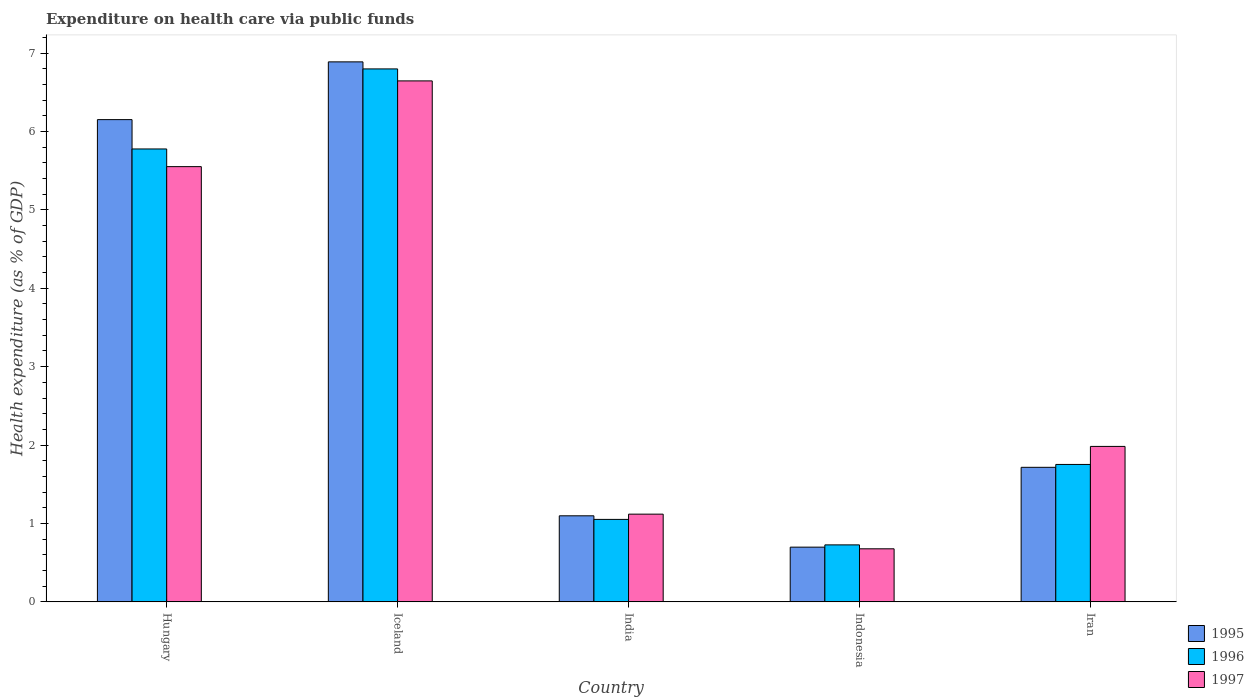How many groups of bars are there?
Ensure brevity in your answer.  5. Are the number of bars on each tick of the X-axis equal?
Give a very brief answer. Yes. What is the label of the 4th group of bars from the left?
Your answer should be compact. Indonesia. What is the expenditure made on health care in 1997 in Indonesia?
Ensure brevity in your answer.  0.68. Across all countries, what is the maximum expenditure made on health care in 1996?
Ensure brevity in your answer.  6.8. Across all countries, what is the minimum expenditure made on health care in 1996?
Offer a very short reply. 0.73. In which country was the expenditure made on health care in 1996 minimum?
Your response must be concise. Indonesia. What is the total expenditure made on health care in 1995 in the graph?
Offer a terse response. 16.55. What is the difference between the expenditure made on health care in 1995 in Hungary and that in India?
Provide a succinct answer. 5.05. What is the difference between the expenditure made on health care in 1997 in Iceland and the expenditure made on health care in 1995 in Iran?
Your answer should be compact. 4.93. What is the average expenditure made on health care in 1995 per country?
Ensure brevity in your answer.  3.31. What is the difference between the expenditure made on health care of/in 1995 and expenditure made on health care of/in 1996 in India?
Make the answer very short. 0.05. In how many countries, is the expenditure made on health care in 1995 greater than 5.6 %?
Ensure brevity in your answer.  2. What is the ratio of the expenditure made on health care in 1996 in India to that in Iran?
Ensure brevity in your answer.  0.6. Is the difference between the expenditure made on health care in 1995 in Hungary and India greater than the difference between the expenditure made on health care in 1996 in Hungary and India?
Ensure brevity in your answer.  Yes. What is the difference between the highest and the second highest expenditure made on health care in 1997?
Offer a very short reply. -3.57. What is the difference between the highest and the lowest expenditure made on health care in 1995?
Provide a short and direct response. 6.19. Is the sum of the expenditure made on health care in 1996 in India and Indonesia greater than the maximum expenditure made on health care in 1997 across all countries?
Offer a terse response. No. What does the 2nd bar from the left in Hungary represents?
Your response must be concise. 1996. How many bars are there?
Offer a very short reply. 15. Are the values on the major ticks of Y-axis written in scientific E-notation?
Provide a short and direct response. No. Does the graph contain any zero values?
Provide a short and direct response. No. Does the graph contain grids?
Provide a short and direct response. No. Where does the legend appear in the graph?
Provide a succinct answer. Bottom right. How many legend labels are there?
Offer a terse response. 3. How are the legend labels stacked?
Make the answer very short. Vertical. What is the title of the graph?
Provide a succinct answer. Expenditure on health care via public funds. Does "2001" appear as one of the legend labels in the graph?
Your answer should be very brief. No. What is the label or title of the Y-axis?
Make the answer very short. Health expenditure (as % of GDP). What is the Health expenditure (as % of GDP) in 1995 in Hungary?
Make the answer very short. 6.15. What is the Health expenditure (as % of GDP) in 1996 in Hungary?
Offer a terse response. 5.78. What is the Health expenditure (as % of GDP) in 1997 in Hungary?
Provide a short and direct response. 5.55. What is the Health expenditure (as % of GDP) of 1995 in Iceland?
Keep it short and to the point. 6.89. What is the Health expenditure (as % of GDP) of 1996 in Iceland?
Your answer should be compact. 6.8. What is the Health expenditure (as % of GDP) of 1997 in Iceland?
Ensure brevity in your answer.  6.64. What is the Health expenditure (as % of GDP) in 1995 in India?
Ensure brevity in your answer.  1.1. What is the Health expenditure (as % of GDP) of 1996 in India?
Provide a short and direct response. 1.05. What is the Health expenditure (as % of GDP) in 1997 in India?
Offer a very short reply. 1.12. What is the Health expenditure (as % of GDP) in 1995 in Indonesia?
Your answer should be very brief. 0.7. What is the Health expenditure (as % of GDP) of 1996 in Indonesia?
Provide a succinct answer. 0.73. What is the Health expenditure (as % of GDP) in 1997 in Indonesia?
Give a very brief answer. 0.68. What is the Health expenditure (as % of GDP) in 1995 in Iran?
Make the answer very short. 1.72. What is the Health expenditure (as % of GDP) in 1996 in Iran?
Provide a short and direct response. 1.75. What is the Health expenditure (as % of GDP) in 1997 in Iran?
Offer a terse response. 1.98. Across all countries, what is the maximum Health expenditure (as % of GDP) in 1995?
Keep it short and to the point. 6.89. Across all countries, what is the maximum Health expenditure (as % of GDP) in 1996?
Your answer should be compact. 6.8. Across all countries, what is the maximum Health expenditure (as % of GDP) in 1997?
Your response must be concise. 6.64. Across all countries, what is the minimum Health expenditure (as % of GDP) of 1995?
Keep it short and to the point. 0.7. Across all countries, what is the minimum Health expenditure (as % of GDP) of 1996?
Offer a very short reply. 0.73. Across all countries, what is the minimum Health expenditure (as % of GDP) in 1997?
Offer a terse response. 0.68. What is the total Health expenditure (as % of GDP) of 1995 in the graph?
Provide a succinct answer. 16.55. What is the total Health expenditure (as % of GDP) in 1996 in the graph?
Make the answer very short. 16.11. What is the total Health expenditure (as % of GDP) of 1997 in the graph?
Your answer should be very brief. 15.97. What is the difference between the Health expenditure (as % of GDP) of 1995 in Hungary and that in Iceland?
Keep it short and to the point. -0.74. What is the difference between the Health expenditure (as % of GDP) of 1996 in Hungary and that in Iceland?
Keep it short and to the point. -1.02. What is the difference between the Health expenditure (as % of GDP) in 1997 in Hungary and that in Iceland?
Your response must be concise. -1.09. What is the difference between the Health expenditure (as % of GDP) in 1995 in Hungary and that in India?
Your answer should be compact. 5.05. What is the difference between the Health expenditure (as % of GDP) in 1996 in Hungary and that in India?
Give a very brief answer. 4.72. What is the difference between the Health expenditure (as % of GDP) of 1997 in Hungary and that in India?
Provide a succinct answer. 4.43. What is the difference between the Health expenditure (as % of GDP) of 1995 in Hungary and that in Indonesia?
Keep it short and to the point. 5.45. What is the difference between the Health expenditure (as % of GDP) of 1996 in Hungary and that in Indonesia?
Ensure brevity in your answer.  5.05. What is the difference between the Health expenditure (as % of GDP) in 1997 in Hungary and that in Indonesia?
Provide a succinct answer. 4.87. What is the difference between the Health expenditure (as % of GDP) of 1995 in Hungary and that in Iran?
Give a very brief answer. 4.43. What is the difference between the Health expenditure (as % of GDP) in 1996 in Hungary and that in Iran?
Ensure brevity in your answer.  4.02. What is the difference between the Health expenditure (as % of GDP) in 1997 in Hungary and that in Iran?
Your answer should be very brief. 3.57. What is the difference between the Health expenditure (as % of GDP) in 1995 in Iceland and that in India?
Your response must be concise. 5.79. What is the difference between the Health expenditure (as % of GDP) in 1996 in Iceland and that in India?
Your answer should be very brief. 5.75. What is the difference between the Health expenditure (as % of GDP) in 1997 in Iceland and that in India?
Ensure brevity in your answer.  5.53. What is the difference between the Health expenditure (as % of GDP) of 1995 in Iceland and that in Indonesia?
Your response must be concise. 6.19. What is the difference between the Health expenditure (as % of GDP) of 1996 in Iceland and that in Indonesia?
Ensure brevity in your answer.  6.07. What is the difference between the Health expenditure (as % of GDP) in 1997 in Iceland and that in Indonesia?
Provide a short and direct response. 5.97. What is the difference between the Health expenditure (as % of GDP) of 1995 in Iceland and that in Iran?
Provide a short and direct response. 5.17. What is the difference between the Health expenditure (as % of GDP) in 1996 in Iceland and that in Iran?
Offer a terse response. 5.04. What is the difference between the Health expenditure (as % of GDP) of 1997 in Iceland and that in Iran?
Keep it short and to the point. 4.66. What is the difference between the Health expenditure (as % of GDP) in 1995 in India and that in Indonesia?
Give a very brief answer. 0.4. What is the difference between the Health expenditure (as % of GDP) in 1996 in India and that in Indonesia?
Ensure brevity in your answer.  0.33. What is the difference between the Health expenditure (as % of GDP) in 1997 in India and that in Indonesia?
Make the answer very short. 0.44. What is the difference between the Health expenditure (as % of GDP) in 1995 in India and that in Iran?
Offer a very short reply. -0.62. What is the difference between the Health expenditure (as % of GDP) in 1996 in India and that in Iran?
Your answer should be compact. -0.7. What is the difference between the Health expenditure (as % of GDP) in 1997 in India and that in Iran?
Make the answer very short. -0.86. What is the difference between the Health expenditure (as % of GDP) in 1995 in Indonesia and that in Iran?
Provide a short and direct response. -1.02. What is the difference between the Health expenditure (as % of GDP) of 1996 in Indonesia and that in Iran?
Keep it short and to the point. -1.03. What is the difference between the Health expenditure (as % of GDP) of 1997 in Indonesia and that in Iran?
Provide a succinct answer. -1.31. What is the difference between the Health expenditure (as % of GDP) of 1995 in Hungary and the Health expenditure (as % of GDP) of 1996 in Iceland?
Provide a succinct answer. -0.65. What is the difference between the Health expenditure (as % of GDP) of 1995 in Hungary and the Health expenditure (as % of GDP) of 1997 in Iceland?
Give a very brief answer. -0.49. What is the difference between the Health expenditure (as % of GDP) of 1996 in Hungary and the Health expenditure (as % of GDP) of 1997 in Iceland?
Give a very brief answer. -0.87. What is the difference between the Health expenditure (as % of GDP) of 1995 in Hungary and the Health expenditure (as % of GDP) of 1996 in India?
Keep it short and to the point. 5.1. What is the difference between the Health expenditure (as % of GDP) of 1995 in Hungary and the Health expenditure (as % of GDP) of 1997 in India?
Your answer should be compact. 5.03. What is the difference between the Health expenditure (as % of GDP) of 1996 in Hungary and the Health expenditure (as % of GDP) of 1997 in India?
Make the answer very short. 4.66. What is the difference between the Health expenditure (as % of GDP) of 1995 in Hungary and the Health expenditure (as % of GDP) of 1996 in Indonesia?
Ensure brevity in your answer.  5.42. What is the difference between the Health expenditure (as % of GDP) in 1995 in Hungary and the Health expenditure (as % of GDP) in 1997 in Indonesia?
Your response must be concise. 5.47. What is the difference between the Health expenditure (as % of GDP) in 1996 in Hungary and the Health expenditure (as % of GDP) in 1997 in Indonesia?
Give a very brief answer. 5.1. What is the difference between the Health expenditure (as % of GDP) of 1995 in Hungary and the Health expenditure (as % of GDP) of 1996 in Iran?
Your response must be concise. 4.4. What is the difference between the Health expenditure (as % of GDP) of 1995 in Hungary and the Health expenditure (as % of GDP) of 1997 in Iran?
Provide a short and direct response. 4.17. What is the difference between the Health expenditure (as % of GDP) in 1996 in Hungary and the Health expenditure (as % of GDP) in 1997 in Iran?
Make the answer very short. 3.79. What is the difference between the Health expenditure (as % of GDP) in 1995 in Iceland and the Health expenditure (as % of GDP) in 1996 in India?
Give a very brief answer. 5.84. What is the difference between the Health expenditure (as % of GDP) of 1995 in Iceland and the Health expenditure (as % of GDP) of 1997 in India?
Your answer should be very brief. 5.77. What is the difference between the Health expenditure (as % of GDP) in 1996 in Iceland and the Health expenditure (as % of GDP) in 1997 in India?
Your response must be concise. 5.68. What is the difference between the Health expenditure (as % of GDP) in 1995 in Iceland and the Health expenditure (as % of GDP) in 1996 in Indonesia?
Make the answer very short. 6.16. What is the difference between the Health expenditure (as % of GDP) of 1995 in Iceland and the Health expenditure (as % of GDP) of 1997 in Indonesia?
Offer a terse response. 6.21. What is the difference between the Health expenditure (as % of GDP) of 1996 in Iceland and the Health expenditure (as % of GDP) of 1997 in Indonesia?
Your answer should be compact. 6.12. What is the difference between the Health expenditure (as % of GDP) in 1995 in Iceland and the Health expenditure (as % of GDP) in 1996 in Iran?
Ensure brevity in your answer.  5.13. What is the difference between the Health expenditure (as % of GDP) of 1995 in Iceland and the Health expenditure (as % of GDP) of 1997 in Iran?
Ensure brevity in your answer.  4.9. What is the difference between the Health expenditure (as % of GDP) in 1996 in Iceland and the Health expenditure (as % of GDP) in 1997 in Iran?
Offer a terse response. 4.81. What is the difference between the Health expenditure (as % of GDP) in 1995 in India and the Health expenditure (as % of GDP) in 1996 in Indonesia?
Make the answer very short. 0.37. What is the difference between the Health expenditure (as % of GDP) in 1995 in India and the Health expenditure (as % of GDP) in 1997 in Indonesia?
Your answer should be compact. 0.42. What is the difference between the Health expenditure (as % of GDP) in 1995 in India and the Health expenditure (as % of GDP) in 1996 in Iran?
Offer a very short reply. -0.66. What is the difference between the Health expenditure (as % of GDP) of 1995 in India and the Health expenditure (as % of GDP) of 1997 in Iran?
Ensure brevity in your answer.  -0.89. What is the difference between the Health expenditure (as % of GDP) in 1996 in India and the Health expenditure (as % of GDP) in 1997 in Iran?
Offer a very short reply. -0.93. What is the difference between the Health expenditure (as % of GDP) of 1995 in Indonesia and the Health expenditure (as % of GDP) of 1996 in Iran?
Keep it short and to the point. -1.05. What is the difference between the Health expenditure (as % of GDP) in 1995 in Indonesia and the Health expenditure (as % of GDP) in 1997 in Iran?
Ensure brevity in your answer.  -1.28. What is the difference between the Health expenditure (as % of GDP) of 1996 in Indonesia and the Health expenditure (as % of GDP) of 1997 in Iran?
Your answer should be compact. -1.26. What is the average Health expenditure (as % of GDP) of 1995 per country?
Your answer should be very brief. 3.31. What is the average Health expenditure (as % of GDP) in 1996 per country?
Ensure brevity in your answer.  3.22. What is the average Health expenditure (as % of GDP) in 1997 per country?
Make the answer very short. 3.19. What is the difference between the Health expenditure (as % of GDP) of 1995 and Health expenditure (as % of GDP) of 1996 in Hungary?
Give a very brief answer. 0.37. What is the difference between the Health expenditure (as % of GDP) of 1995 and Health expenditure (as % of GDP) of 1997 in Hungary?
Give a very brief answer. 0.6. What is the difference between the Health expenditure (as % of GDP) in 1996 and Health expenditure (as % of GDP) in 1997 in Hungary?
Your answer should be very brief. 0.23. What is the difference between the Health expenditure (as % of GDP) in 1995 and Health expenditure (as % of GDP) in 1996 in Iceland?
Give a very brief answer. 0.09. What is the difference between the Health expenditure (as % of GDP) of 1995 and Health expenditure (as % of GDP) of 1997 in Iceland?
Provide a succinct answer. 0.24. What is the difference between the Health expenditure (as % of GDP) of 1996 and Health expenditure (as % of GDP) of 1997 in Iceland?
Make the answer very short. 0.15. What is the difference between the Health expenditure (as % of GDP) in 1995 and Health expenditure (as % of GDP) in 1996 in India?
Your answer should be very brief. 0.05. What is the difference between the Health expenditure (as % of GDP) in 1995 and Health expenditure (as % of GDP) in 1997 in India?
Offer a very short reply. -0.02. What is the difference between the Health expenditure (as % of GDP) of 1996 and Health expenditure (as % of GDP) of 1997 in India?
Provide a short and direct response. -0.07. What is the difference between the Health expenditure (as % of GDP) of 1995 and Health expenditure (as % of GDP) of 1996 in Indonesia?
Keep it short and to the point. -0.03. What is the difference between the Health expenditure (as % of GDP) of 1995 and Health expenditure (as % of GDP) of 1997 in Indonesia?
Offer a terse response. 0.02. What is the difference between the Health expenditure (as % of GDP) of 1996 and Health expenditure (as % of GDP) of 1997 in Indonesia?
Your response must be concise. 0.05. What is the difference between the Health expenditure (as % of GDP) in 1995 and Health expenditure (as % of GDP) in 1996 in Iran?
Offer a very short reply. -0.04. What is the difference between the Health expenditure (as % of GDP) in 1995 and Health expenditure (as % of GDP) in 1997 in Iran?
Ensure brevity in your answer.  -0.27. What is the difference between the Health expenditure (as % of GDP) in 1996 and Health expenditure (as % of GDP) in 1997 in Iran?
Your answer should be compact. -0.23. What is the ratio of the Health expenditure (as % of GDP) of 1995 in Hungary to that in Iceland?
Provide a short and direct response. 0.89. What is the ratio of the Health expenditure (as % of GDP) in 1996 in Hungary to that in Iceland?
Your answer should be compact. 0.85. What is the ratio of the Health expenditure (as % of GDP) in 1997 in Hungary to that in Iceland?
Offer a very short reply. 0.84. What is the ratio of the Health expenditure (as % of GDP) in 1995 in Hungary to that in India?
Your response must be concise. 5.6. What is the ratio of the Health expenditure (as % of GDP) in 1996 in Hungary to that in India?
Make the answer very short. 5.49. What is the ratio of the Health expenditure (as % of GDP) in 1997 in Hungary to that in India?
Provide a short and direct response. 4.96. What is the ratio of the Health expenditure (as % of GDP) in 1995 in Hungary to that in Indonesia?
Your answer should be compact. 8.81. What is the ratio of the Health expenditure (as % of GDP) in 1996 in Hungary to that in Indonesia?
Keep it short and to the point. 7.95. What is the ratio of the Health expenditure (as % of GDP) in 1997 in Hungary to that in Indonesia?
Provide a succinct answer. 8.2. What is the ratio of the Health expenditure (as % of GDP) in 1995 in Hungary to that in Iran?
Ensure brevity in your answer.  3.58. What is the ratio of the Health expenditure (as % of GDP) in 1996 in Hungary to that in Iran?
Keep it short and to the point. 3.3. What is the ratio of the Health expenditure (as % of GDP) of 1997 in Hungary to that in Iran?
Your answer should be very brief. 2.8. What is the ratio of the Health expenditure (as % of GDP) of 1995 in Iceland to that in India?
Your answer should be very brief. 6.27. What is the ratio of the Health expenditure (as % of GDP) in 1996 in Iceland to that in India?
Ensure brevity in your answer.  6.46. What is the ratio of the Health expenditure (as % of GDP) of 1997 in Iceland to that in India?
Your answer should be very brief. 5.94. What is the ratio of the Health expenditure (as % of GDP) in 1995 in Iceland to that in Indonesia?
Give a very brief answer. 9.87. What is the ratio of the Health expenditure (as % of GDP) in 1996 in Iceland to that in Indonesia?
Your response must be concise. 9.35. What is the ratio of the Health expenditure (as % of GDP) in 1997 in Iceland to that in Indonesia?
Keep it short and to the point. 9.82. What is the ratio of the Health expenditure (as % of GDP) in 1995 in Iceland to that in Iran?
Keep it short and to the point. 4.01. What is the ratio of the Health expenditure (as % of GDP) of 1996 in Iceland to that in Iran?
Make the answer very short. 3.88. What is the ratio of the Health expenditure (as % of GDP) of 1997 in Iceland to that in Iran?
Your answer should be compact. 3.35. What is the ratio of the Health expenditure (as % of GDP) of 1995 in India to that in Indonesia?
Provide a short and direct response. 1.57. What is the ratio of the Health expenditure (as % of GDP) of 1996 in India to that in Indonesia?
Offer a terse response. 1.45. What is the ratio of the Health expenditure (as % of GDP) in 1997 in India to that in Indonesia?
Offer a terse response. 1.65. What is the ratio of the Health expenditure (as % of GDP) in 1995 in India to that in Iran?
Ensure brevity in your answer.  0.64. What is the ratio of the Health expenditure (as % of GDP) in 1996 in India to that in Iran?
Your answer should be compact. 0.6. What is the ratio of the Health expenditure (as % of GDP) of 1997 in India to that in Iran?
Make the answer very short. 0.56. What is the ratio of the Health expenditure (as % of GDP) of 1995 in Indonesia to that in Iran?
Your answer should be compact. 0.41. What is the ratio of the Health expenditure (as % of GDP) of 1996 in Indonesia to that in Iran?
Provide a succinct answer. 0.41. What is the ratio of the Health expenditure (as % of GDP) of 1997 in Indonesia to that in Iran?
Provide a succinct answer. 0.34. What is the difference between the highest and the second highest Health expenditure (as % of GDP) of 1995?
Offer a terse response. 0.74. What is the difference between the highest and the second highest Health expenditure (as % of GDP) of 1996?
Your answer should be very brief. 1.02. What is the difference between the highest and the second highest Health expenditure (as % of GDP) of 1997?
Offer a very short reply. 1.09. What is the difference between the highest and the lowest Health expenditure (as % of GDP) of 1995?
Offer a terse response. 6.19. What is the difference between the highest and the lowest Health expenditure (as % of GDP) of 1996?
Give a very brief answer. 6.07. What is the difference between the highest and the lowest Health expenditure (as % of GDP) of 1997?
Offer a very short reply. 5.97. 